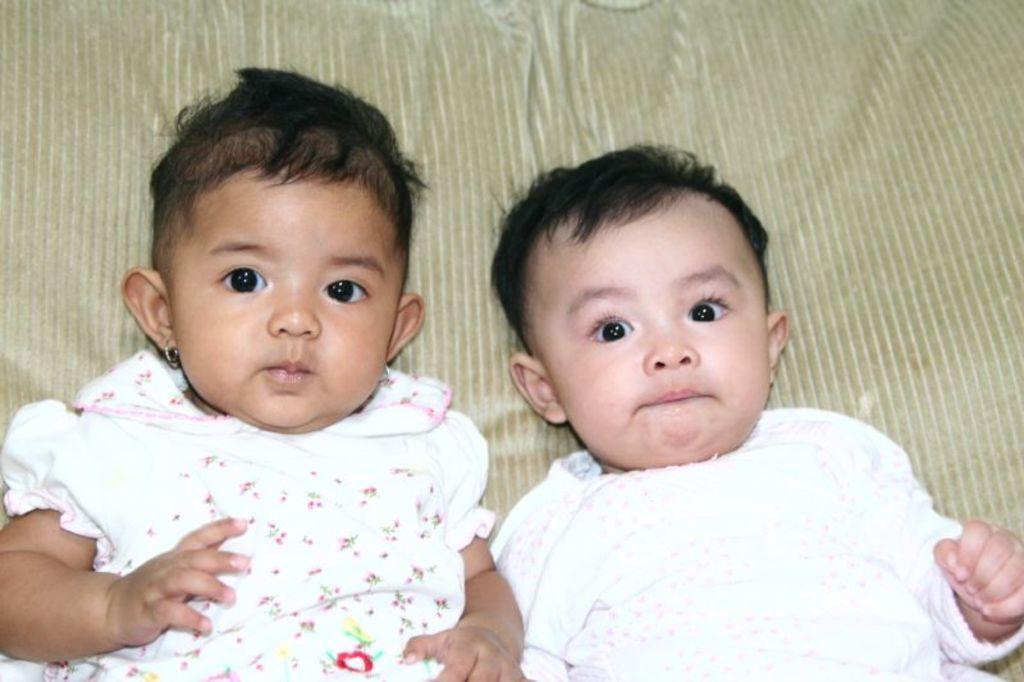Could you give a brief overview of what you see in this image? In this image in the center there are two babies, and in the background there is a blanket. 